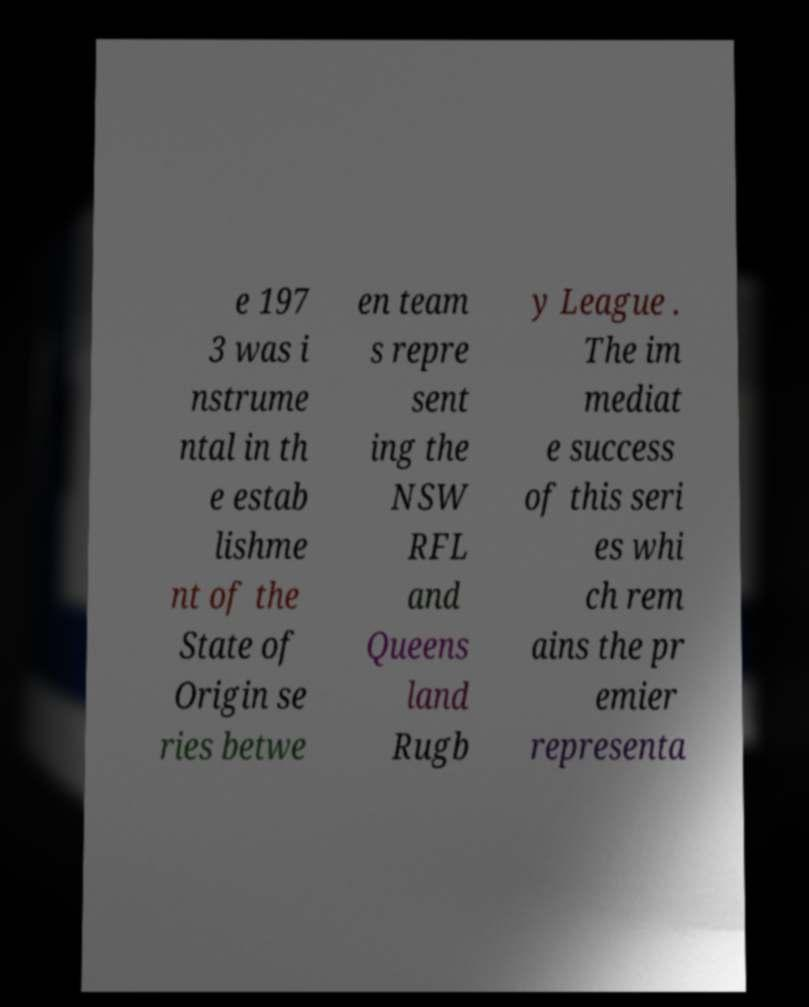Can you read and provide the text displayed in the image?This photo seems to have some interesting text. Can you extract and type it out for me? e 197 3 was i nstrume ntal in th e estab lishme nt of the State of Origin se ries betwe en team s repre sent ing the NSW RFL and Queens land Rugb y League . The im mediat e success of this seri es whi ch rem ains the pr emier representa 